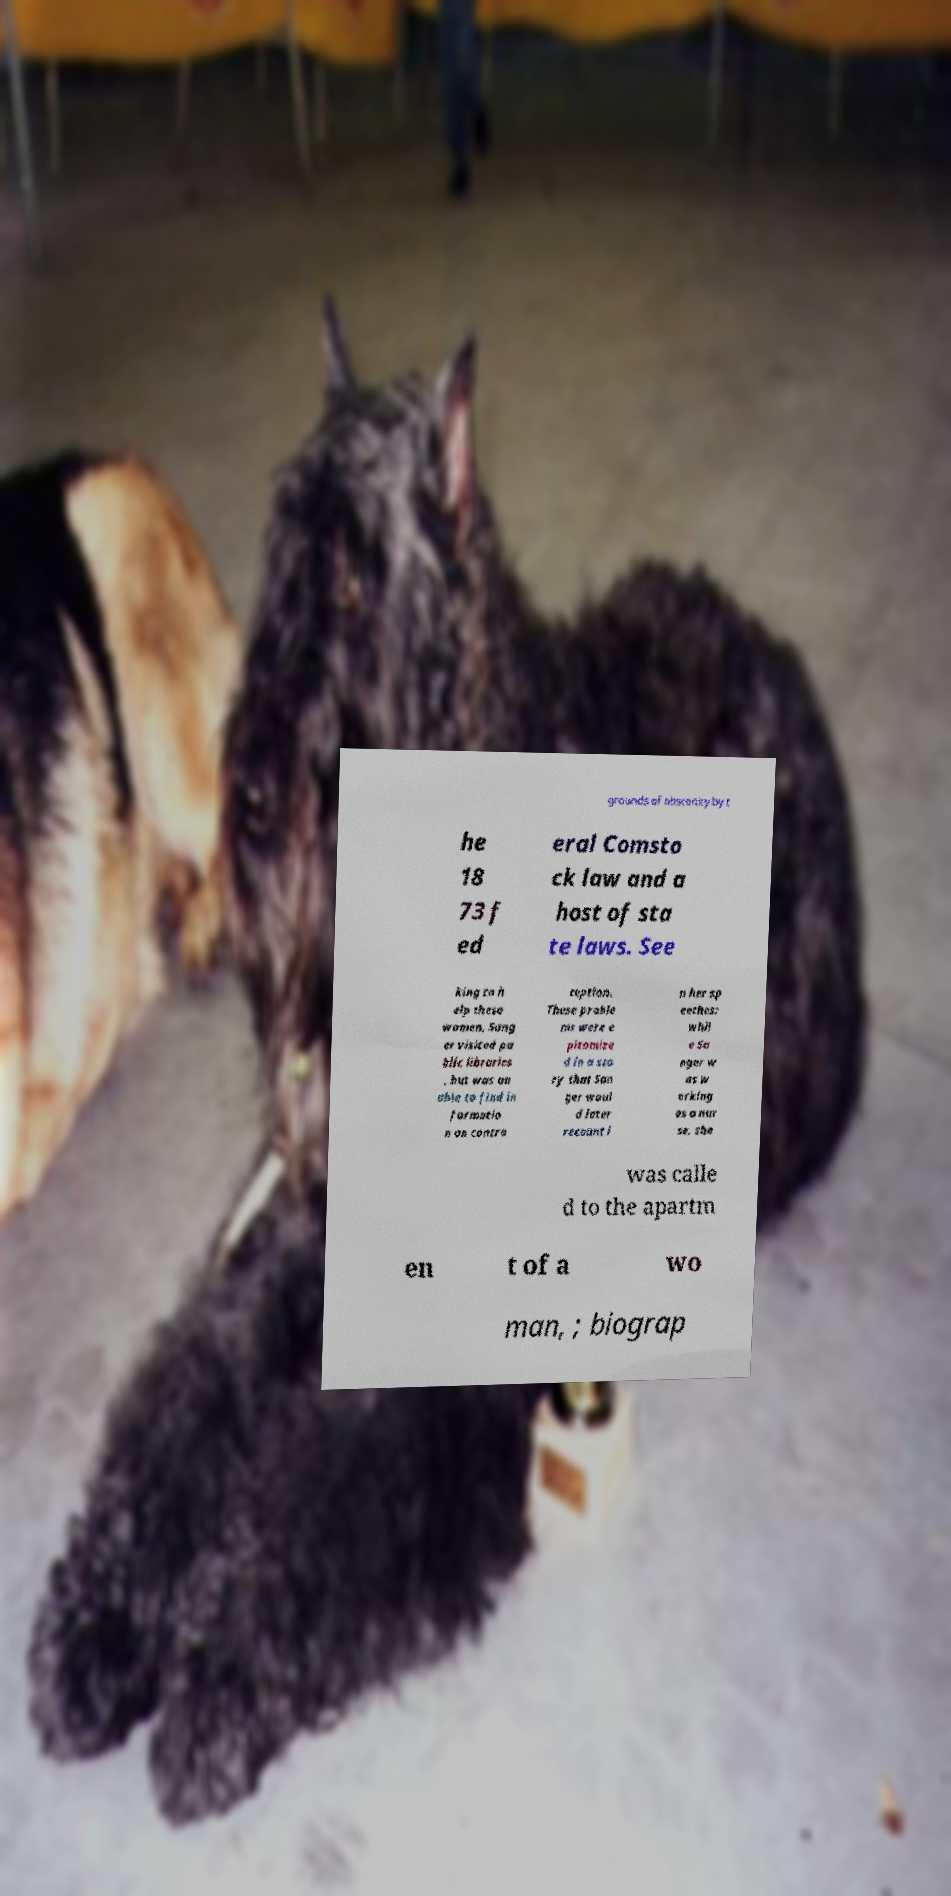Can you accurately transcribe the text from the provided image for me? grounds of obscenity by t he 18 73 f ed eral Comsto ck law and a host of sta te laws. See king to h elp these women, Sang er visited pu blic libraries , but was un able to find in formatio n on contra ception. These proble ms were e pitomize d in a sto ry that San ger woul d later recount i n her sp eeches: whil e Sa nger w as w orking as a nur se, she was calle d to the apartm en t of a wo man, ; biograp 